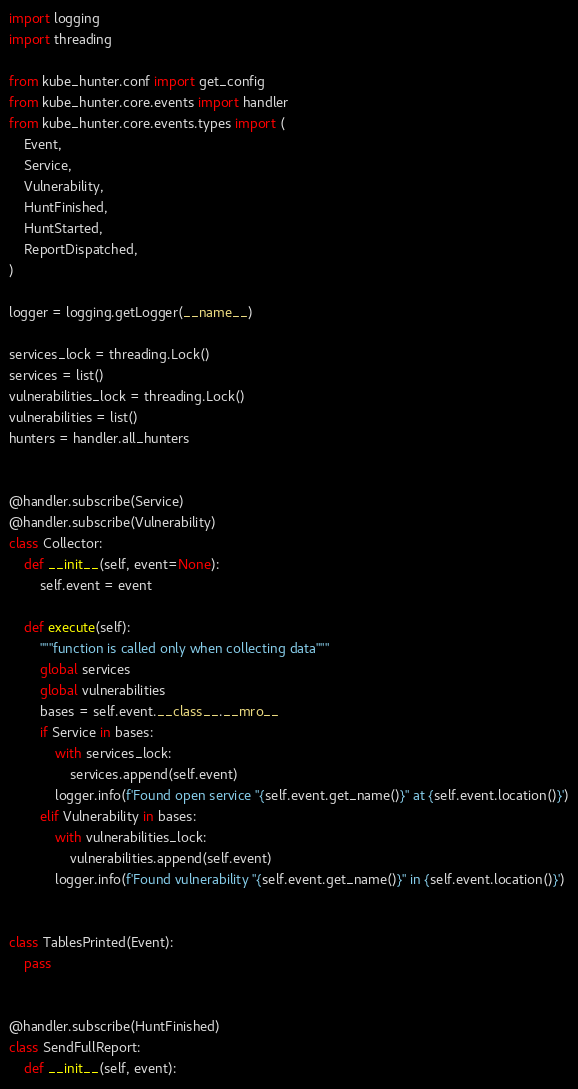<code> <loc_0><loc_0><loc_500><loc_500><_Python_>import logging
import threading

from kube_hunter.conf import get_config
from kube_hunter.core.events import handler
from kube_hunter.core.events.types import (
    Event,
    Service,
    Vulnerability,
    HuntFinished,
    HuntStarted,
    ReportDispatched,
)

logger = logging.getLogger(__name__)

services_lock = threading.Lock()
services = list()
vulnerabilities_lock = threading.Lock()
vulnerabilities = list()
hunters = handler.all_hunters


@handler.subscribe(Service)
@handler.subscribe(Vulnerability)
class Collector:
    def __init__(self, event=None):
        self.event = event

    def execute(self):
        """function is called only when collecting data"""
        global services
        global vulnerabilities
        bases = self.event.__class__.__mro__
        if Service in bases:
            with services_lock:
                services.append(self.event)
            logger.info(f'Found open service "{self.event.get_name()}" at {self.event.location()}')
        elif Vulnerability in bases:
            with vulnerabilities_lock:
                vulnerabilities.append(self.event)
            logger.info(f'Found vulnerability "{self.event.get_name()}" in {self.event.location()}')


class TablesPrinted(Event):
    pass


@handler.subscribe(HuntFinished)
class SendFullReport:
    def __init__(self, event):</code> 